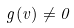<formula> <loc_0><loc_0><loc_500><loc_500>g ( v ) \ne 0</formula> 